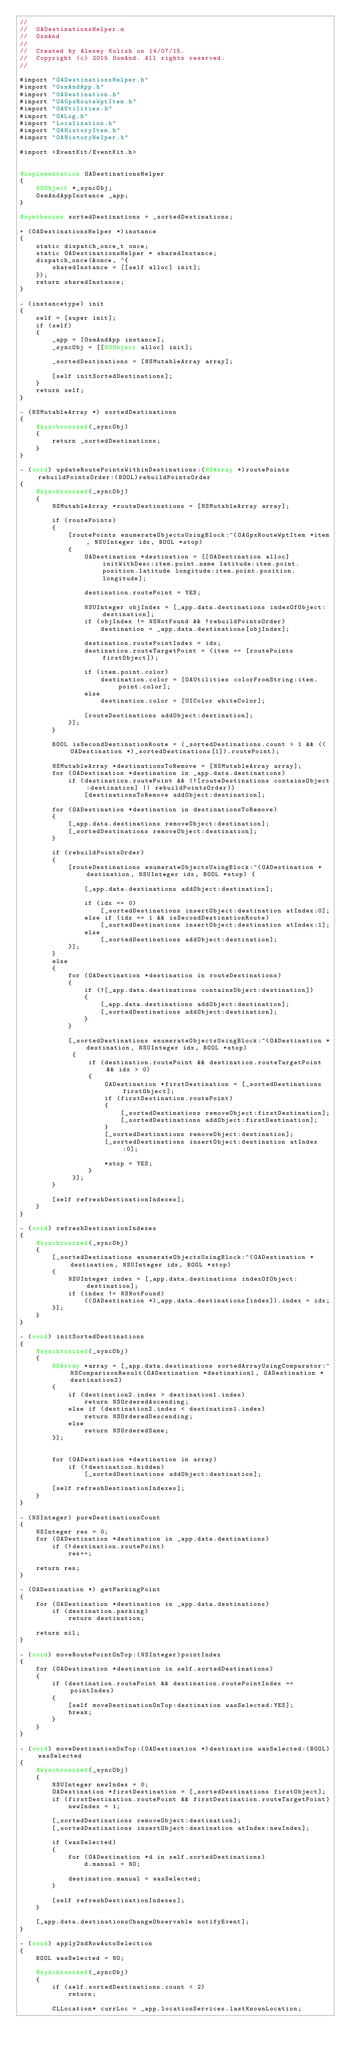Convert code to text. <code><loc_0><loc_0><loc_500><loc_500><_ObjectiveC_>//
//  OADestinationsHelper.m
//  OsmAnd
//
//  Created by Alexey Kulish on 14/07/15.
//  Copyright (c) 2015 OsmAnd. All rights reserved.
//

#import "OADestinationsHelper.h"
#import "OsmAndApp.h"
#import "OADestination.h"
#import "OAGpxRouteWptItem.h"
#import "OAUtilities.h"
#import "OALog.h"
#import "Localization.h"
#import "OAHistoryItem.h"
#import "OAHistoryHelper.h"

#import <EventKit/EventKit.h>


@implementation OADestinationsHelper
{
    NSObject *_syncObj;
    OsmAndAppInstance _app;
}

@synthesize sortedDestinations = _sortedDestinations;

+ (OADestinationsHelper *)instance
{
    static dispatch_once_t once;
    static OADestinationsHelper * sharedInstance;
    dispatch_once(&once, ^{
        sharedInstance = [[self alloc] init];
    });
    return sharedInstance;
}

- (instancetype) init
{
    self = [super init];
    if (self)
    {
        _app = [OsmAndApp instance];
        _syncObj = [[NSObject alloc] init];
        
        _sortedDestinations = [NSMutableArray array];
        
        [self initSortedDestinations];
    }
    return self;
}

- (NSMutableArray *) sortedDestinations
{
    @synchronized(_syncObj)
    {
        return _sortedDestinations;
    }
}

- (void) updateRoutePointsWithinDestinations:(NSArray *)routePoints rebuildPointsOrder:(BOOL)rebuildPointsOrder
{
    @synchronized(_syncObj)
    {
        NSMutableArray *routeDestinations = [NSMutableArray array];
        
        if (routePoints)
        {
            [routePoints enumerateObjectsUsingBlock:^(OAGpxRouteWptItem *item, NSUInteger idx, BOOL *stop)
            {                
                OADestination *destination = [[OADestination alloc] initWithDesc:item.point.name latitude:item.point.position.latitude longitude:item.point.position.longitude];
                
                destination.routePoint = YES;
                
                NSUInteger objIndex = [_app.data.destinations indexOfObject:destination];
                if (objIndex != NSNotFound && !rebuildPointsOrder)
                    destination = _app.data.destinations[objIndex];
                
                destination.routePointIndex = idx;
                destination.routeTargetPoint = (item == [routePoints firstObject]);

                if (item.point.color)
                    destination.color = [OAUtilities colorFromString:item.point.color];
                else
                    destination.color = [UIColor whiteColor];
                
                [routeDestinations addObject:destination];
            }];
        }
        
        BOOL isSecondDestinationRoute = (_sortedDestinations.count > 1 && ((OADestination *)_sortedDestinations[1]).routePoint);

        NSMutableArray *destinationsToRemove = [NSMutableArray array];
        for (OADestination *destination in _app.data.destinations)
            if (destination.routePoint && (![routeDestinations containsObject:destination] || rebuildPointsOrder))
                [destinationsToRemove addObject:destination];
        
        for (OADestination *destination in destinationsToRemove)
        {
            [_app.data.destinations removeObject:destination];
            [_sortedDestinations removeObject:destination];
        }
        
        if (rebuildPointsOrder)
        {
            [routeDestinations enumerateObjectsUsingBlock:^(OADestination *destination, NSUInteger idx, BOOL *stop) {
                
                [_app.data.destinations addObject:destination];

                if (idx == 0)
                    [_sortedDestinations insertObject:destination atIndex:0];
                else if (idx == 1 && isSecondDestinationRoute)
                    [_sortedDestinations insertObject:destination atIndex:1];
                else
                    [_sortedDestinations addObject:destination];
            }];
        }
        else
        {
            for (OADestination *destination in routeDestinations)
            {
                if (![_app.data.destinations containsObject:destination])
                {
                    [_app.data.destinations addObject:destination];
                    [_sortedDestinations addObject:destination];
                }
            }
            
            [_sortedDestinations enumerateObjectsUsingBlock:^(OADestination *destination, NSUInteger idx, BOOL *stop)
             {
                 if (destination.routePoint && destination.routeTargetPoint && idx > 0)
                 {
                     OADestination *firstDestination = [_sortedDestinations firstObject];
                     if (firstDestination.routePoint)
                     {
                         [_sortedDestinations removeObject:firstDestination];
                         [_sortedDestinations addObject:firstDestination];
                     }
                     [_sortedDestinations removeObject:destination];
                     [_sortedDestinations insertObject:destination atIndex:0];
                     
                     *stop = YES;
                 }
             }];
        }
        
        [self refreshDestinationIndexes];
    }
}

- (void) refreshDestinationIndexes
{
    @synchronized(_syncObj)
    {
        [_sortedDestinations enumerateObjectsUsingBlock:^(OADestination *destination, NSUInteger idx, BOOL *stop)
        {
            NSUInteger index = [_app.data.destinations indexOfObject:destination];
            if (index != NSNotFound)
                ((OADestination *)_app.data.destinations[index]).index = idx;
        }];
    }
}

- (void) initSortedDestinations
{
    @synchronized(_syncObj)
    {
        NSArray *array = [_app.data.destinations sortedArrayUsingComparator:^NSComparisonResult(OADestination *destination1, OADestination *destination2)
        {
            if (destination2.index > destination1.index)
                return NSOrderedAscending;
            else if (destination2.index < destination1.index)
                return NSOrderedDescending;
            else
                return NSOrderedSame;
        }];
        
        
        for (OADestination *destination in array)
            if (!destination.hidden)
                [_sortedDestinations addObject:destination];
        
        [self refreshDestinationIndexes];
    }
}

- (NSInteger) pureDestinationsCount
{
    NSInteger res = 0;
    for (OADestination *destination in _app.data.destinations)
        if (!destination.routePoint)
            res++;

    return res;
}

- (OADestination *) getParkingPoint
{
    for (OADestination *destination in _app.data.destinations)
        if (destination.parking)
            return destination;
    
    return nil;
}

- (void) moveRoutePointOnTop:(NSInteger)pointIndex
{
    for (OADestination *destination in self.sortedDestinations)
    {
        if (destination.routePoint && destination.routePointIndex == pointIndex)
        {
            [self moveDestinationOnTop:destination wasSelected:YES];
            break;
        }
    }
}

- (void) moveDestinationOnTop:(OADestination *)destination wasSelected:(BOOL)wasSelected
{
    @synchronized(_syncObj)
    {
        NSUInteger newIndex = 0;
        OADestination *firstDestination = [_sortedDestinations firstObject];
        if (firstDestination.routePoint && firstDestination.routeTargetPoint)
            newIndex = 1;
        
        [_sortedDestinations removeObject:destination];
        [_sortedDestinations insertObject:destination atIndex:newIndex];
        
        if (wasSelected)
        {
            for (OADestination *d in self.sortedDestinations)
                d.manual = NO;
            
            destination.manual = wasSelected;
        }
        
        [self refreshDestinationIndexes];
    }
    
    [_app.data.destinationsChangeObservable notifyEvent];
}

- (void) apply2ndRowAutoSelection
{
    BOOL wasSelected = NO;
    
    @synchronized(_syncObj)
    {
        if (self.sortedDestinations.count < 2)
            return;
        
        CLLocation* currLoc = _app.locationServices.lastKnownLocation;</code> 